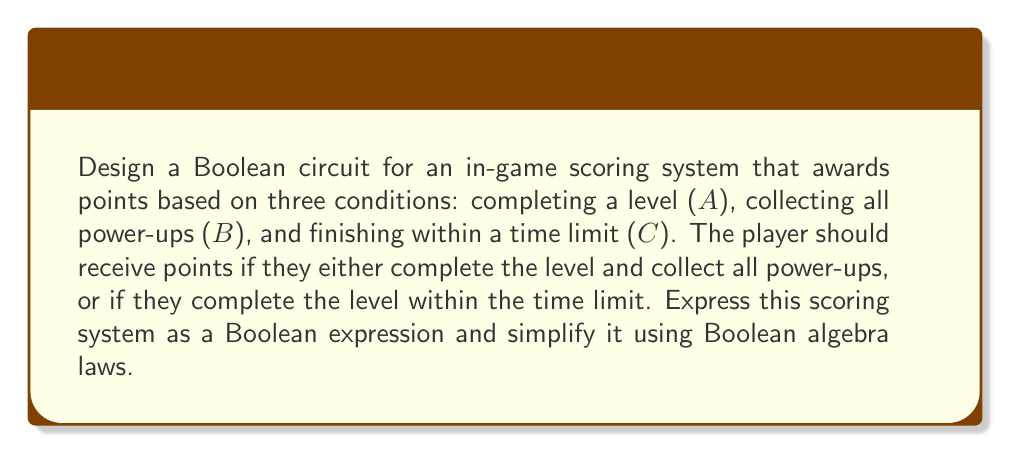Give your solution to this math problem. Let's approach this step-by-step:

1) First, we need to express the scoring conditions in Boolean terms:
   - Complete level AND collect all power-ups: $A \cdot B$
   - Complete level AND finish within time limit: $A \cdot C$

2) The player should receive points if either of these conditions is met. In Boolean algebra, this is represented by the OR operation:

   $$(A \cdot B) + (A \cdot C)$$

3) Now, let's simplify this expression using Boolean algebra laws:

   $$(A \cdot B) + (A \cdot C)$$
   
   We can factor out A using the distributive law:
   
   $$A \cdot (B + C)$$

4) This simplified expression represents our efficient scoring system:
   - A: Complete level
   - (B + C): Either collect all power-ups OR finish within time limit

5) In terms of a Boolean circuit, this would be represented as:

   [asy]
   import geometry;

   // Draw AND gate
   path and = (0,0)--(0,1)--(0.5,1)..tension 1.5..(1,0.5)..(0.5,0)--(0,0);
   draw(shift(1,1)*and);

   // Draw OR gate
   path or = arc((0,0), 1, 90, 270)--arc((0,1), 1, -90, 90)--cycle;
   draw(shift(3,1)*or);

   // Draw inputs and output
   draw((0,1.5)--(1,1.5), arrow=Arrow(TeXHead));
   draw((0,1)--(1,1), arrow=Arrow(TeXHead));
   draw((2,1.5)--(3,1.5), arrow=Arrow(TeXHead));
   draw((2,1)--(3,1), arrow=Arrow(TeXHead));
   draw((4,1.5)--(5,1.5), arrow=Arrow(TeXHead));

   // Label inputs and output
   label("A", (0,1.5), W);
   label("B", (0,1), W);
   label("C", (2,1), W);
   label("Output", (5,1.5), E);
   [/asy]

This circuit efficiently implements the scoring system using only two gates, minimizing computation time in the game engine.
Answer: $A \cdot (B + C)$ 